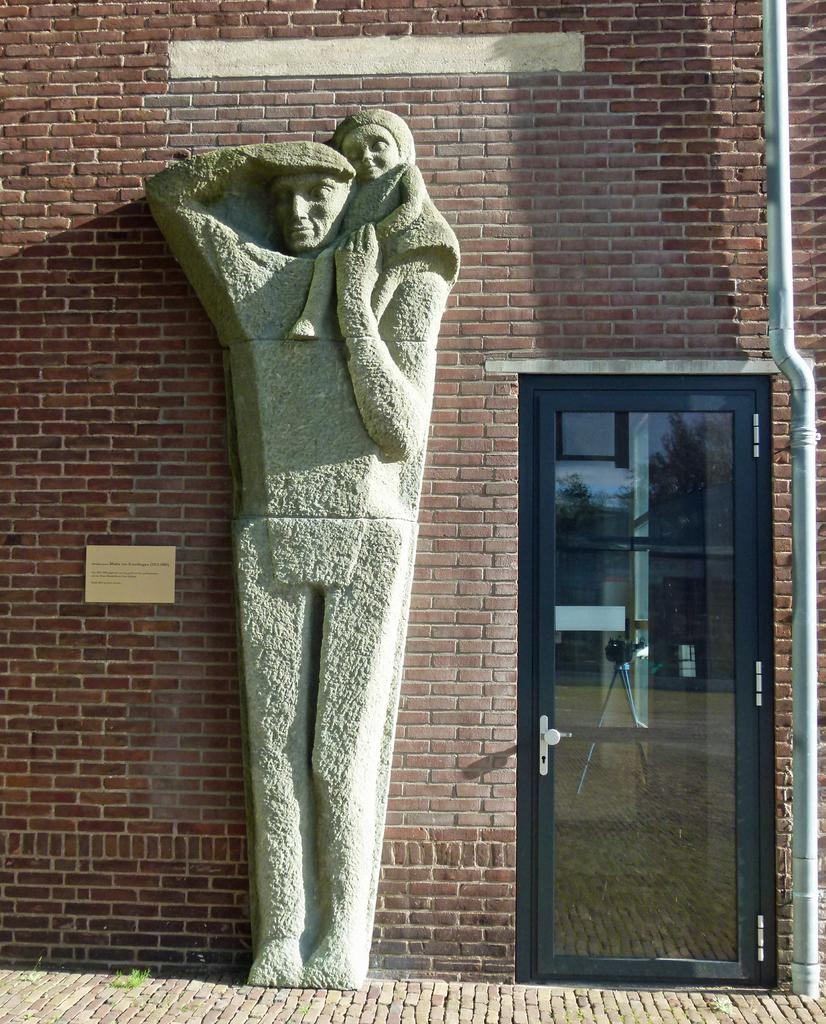What is on the brick wall in the image? There is a sculpture on the brick wall in the image. What is another feature of the wall in the image? There is a door in the image. What else can be seen in the image besides the wall and door? There is a pipeline in the image. What type of quince is hanging from the pipeline in the image? There is no quince present in the image; it features a sculpture on a brick wall, a door, and a pipeline. How does the haircut of the sculpture look like in the image? The sculpture in the image does not have a haircut, as it is not a representation of a person or an animal with hair. 